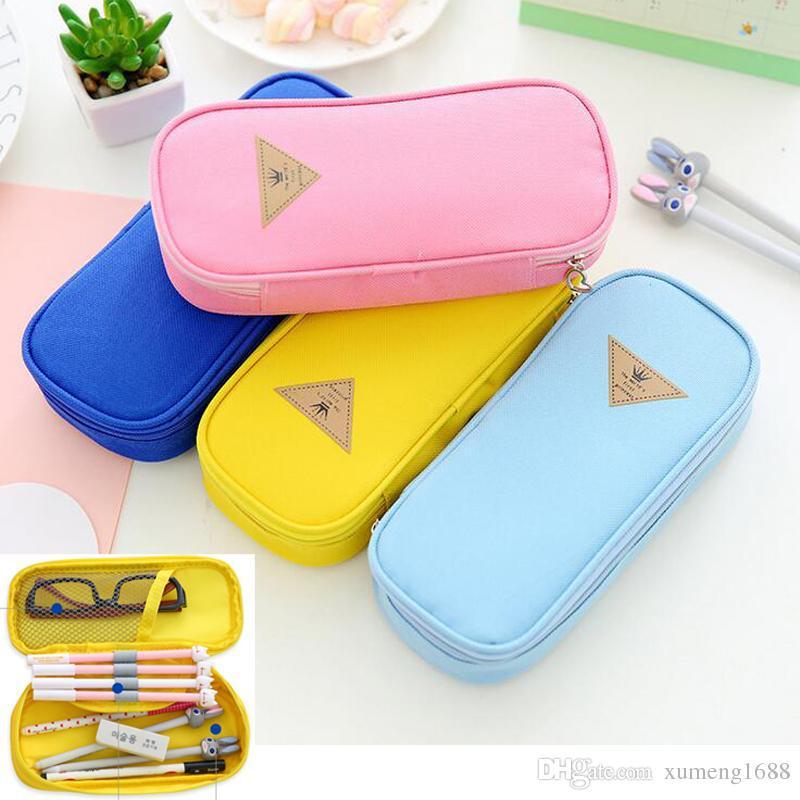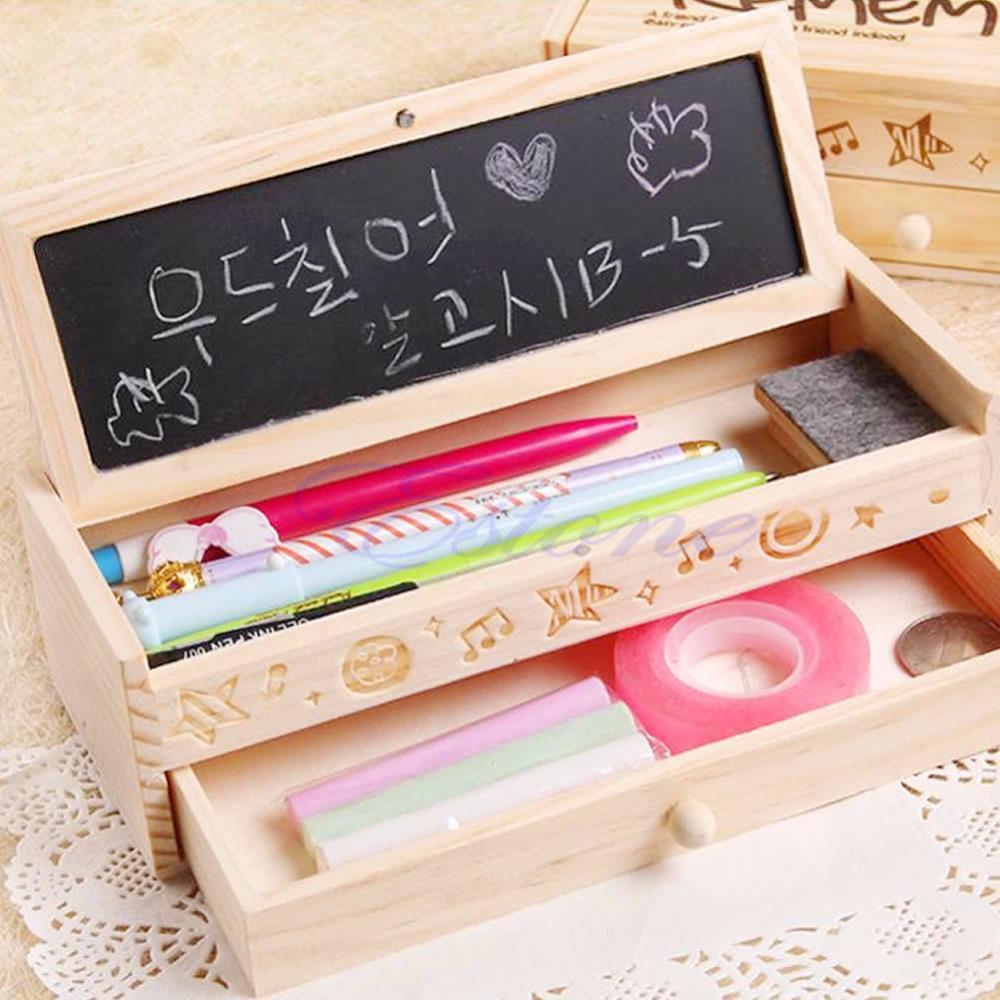The first image is the image on the left, the second image is the image on the right. For the images shown, is this caption "In one image, a wooden pencil case has a drawer pulled out to reveal stowed items and the top raised to show writing tools and a small blackboard with writing on it." true? Answer yes or no. Yes. 